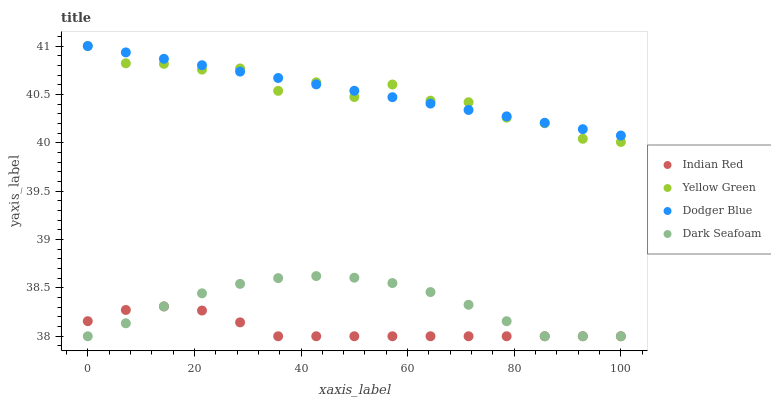Does Indian Red have the minimum area under the curve?
Answer yes or no. Yes. Does Dodger Blue have the maximum area under the curve?
Answer yes or no. Yes. Does Yellow Green have the minimum area under the curve?
Answer yes or no. No. Does Yellow Green have the maximum area under the curve?
Answer yes or no. No. Is Dodger Blue the smoothest?
Answer yes or no. Yes. Is Yellow Green the roughest?
Answer yes or no. Yes. Is Yellow Green the smoothest?
Answer yes or no. No. Is Dodger Blue the roughest?
Answer yes or no. No. Does Dark Seafoam have the lowest value?
Answer yes or no. Yes. Does Yellow Green have the lowest value?
Answer yes or no. No. Does Yellow Green have the highest value?
Answer yes or no. Yes. Does Indian Red have the highest value?
Answer yes or no. No. Is Dark Seafoam less than Dodger Blue?
Answer yes or no. Yes. Is Dodger Blue greater than Indian Red?
Answer yes or no. Yes. Does Indian Red intersect Dark Seafoam?
Answer yes or no. Yes. Is Indian Red less than Dark Seafoam?
Answer yes or no. No. Is Indian Red greater than Dark Seafoam?
Answer yes or no. No. Does Dark Seafoam intersect Dodger Blue?
Answer yes or no. No. 